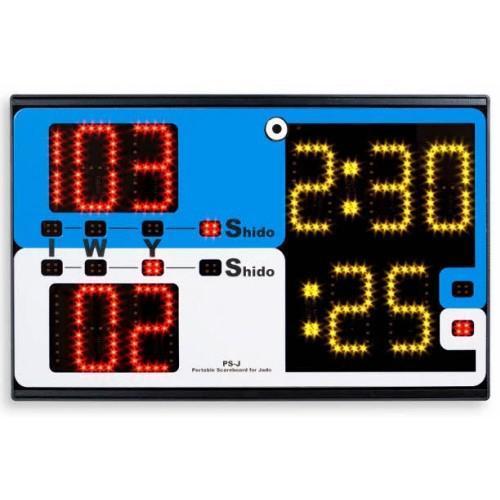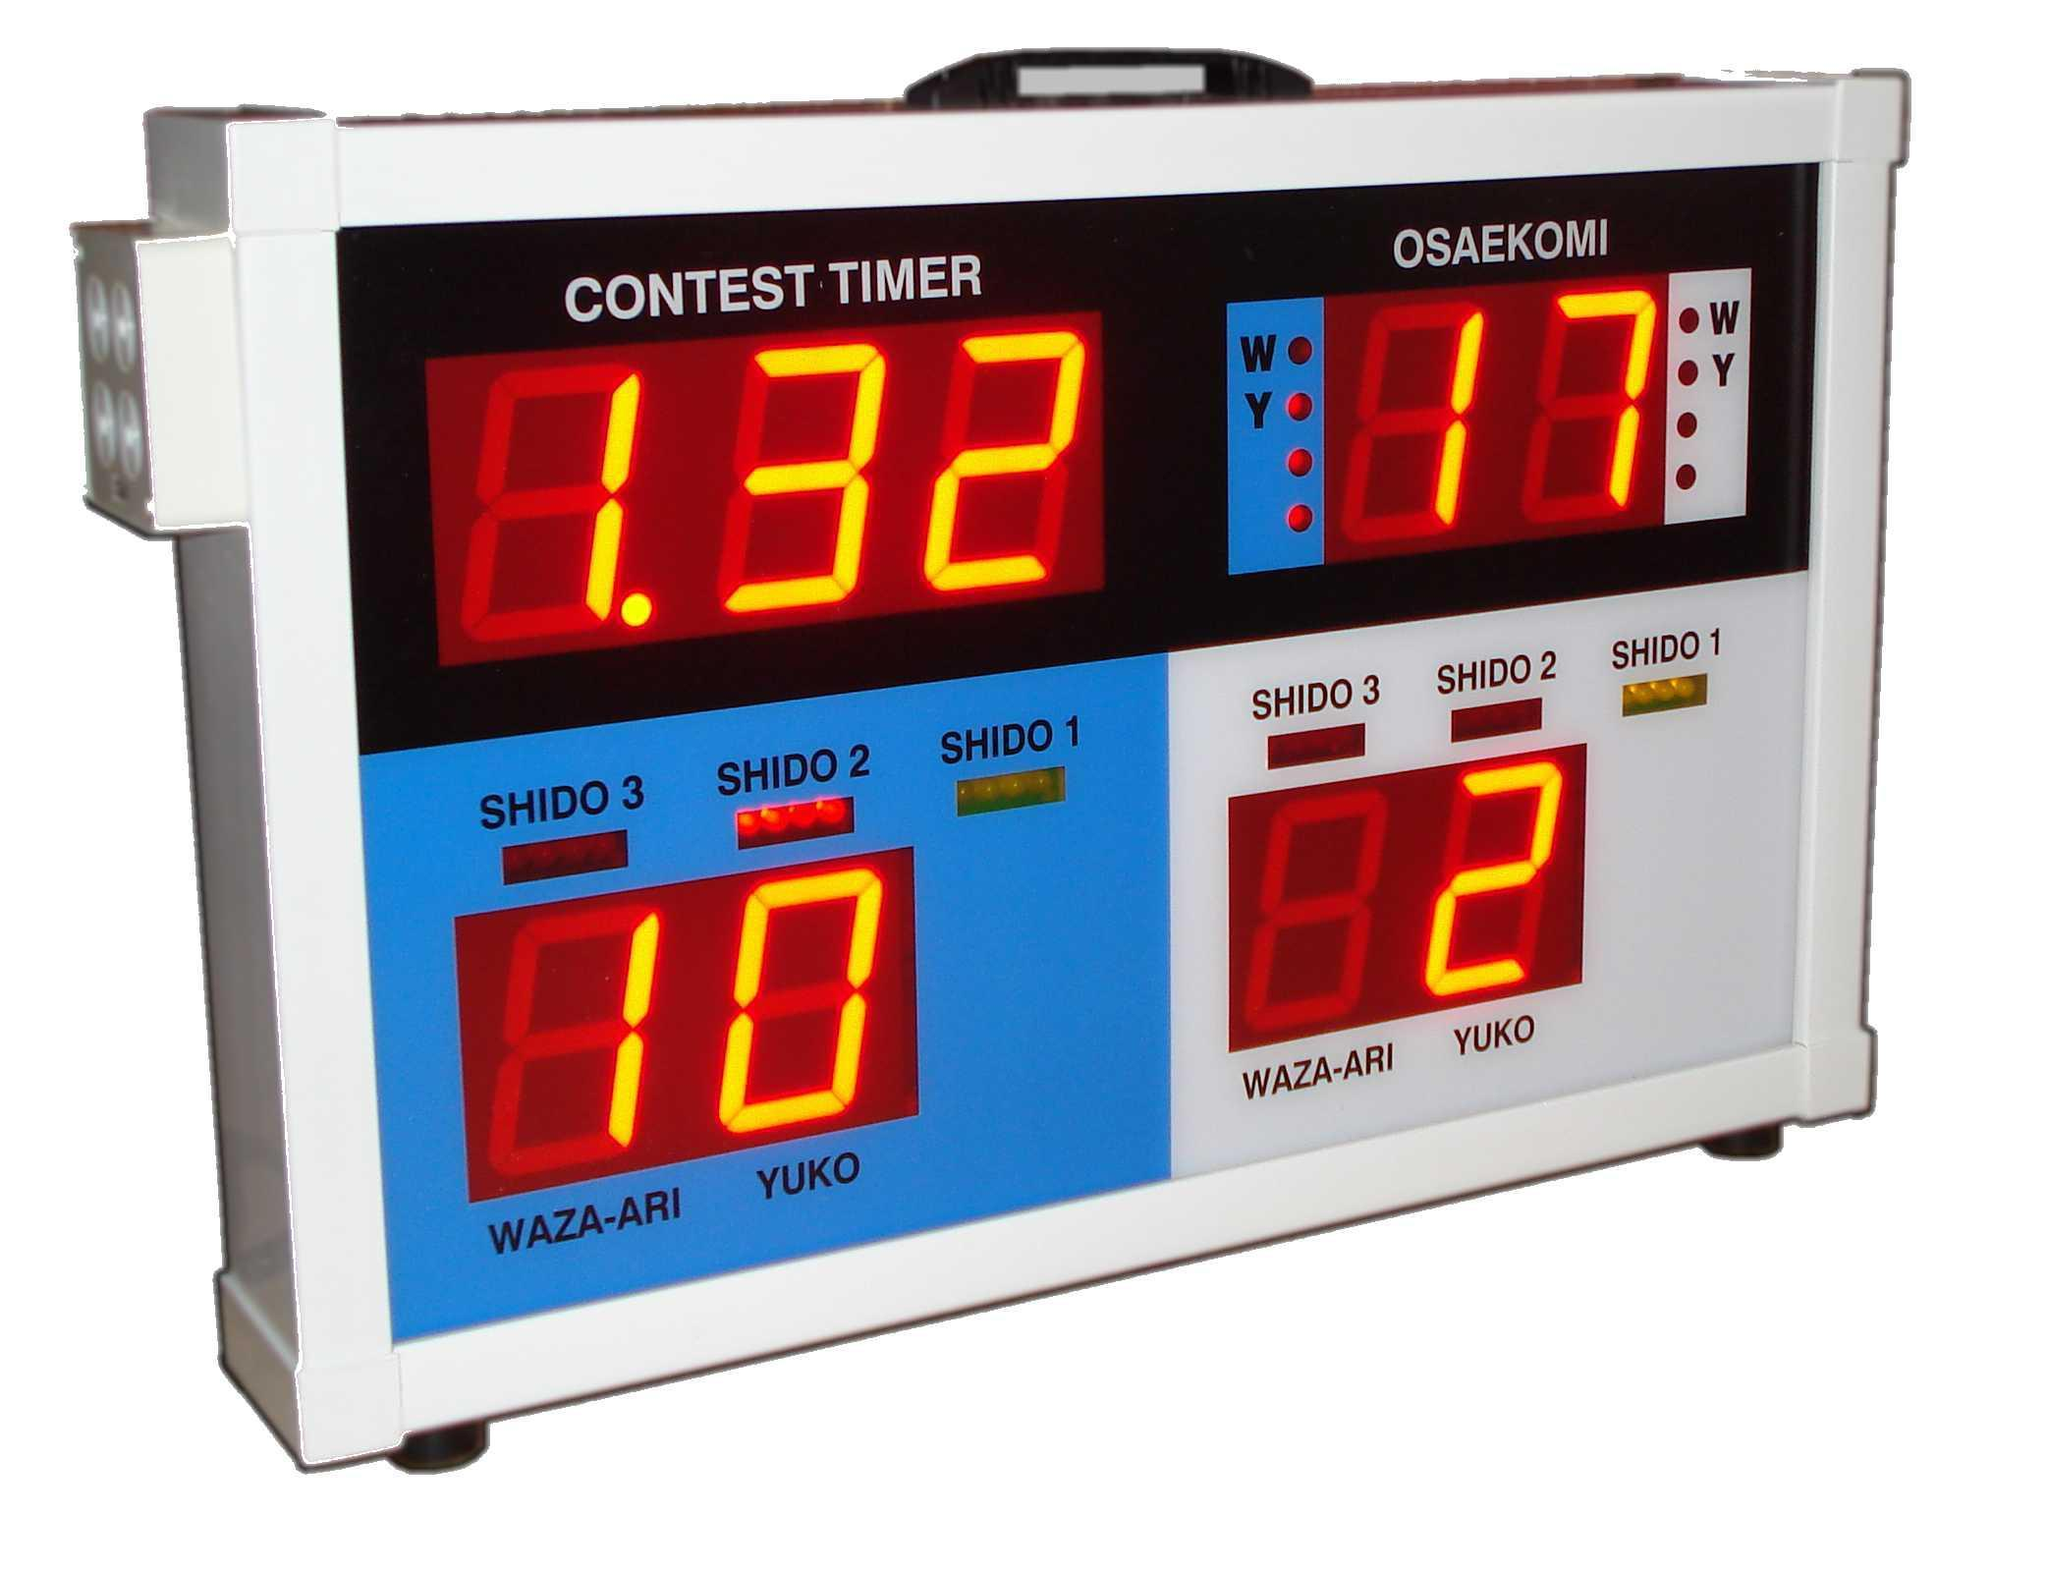The first image is the image on the left, the second image is the image on the right. Considering the images on both sides, is "One of the interfaces contains a weight category." valid? Answer yes or no. No. The first image is the image on the left, the second image is the image on the right. Evaluate the accuracy of this statement regarding the images: "Each scoreboard includes blue and white sections, and one scoreboard has a blue top section and white on the bottom.". Is it true? Answer yes or no. Yes. 